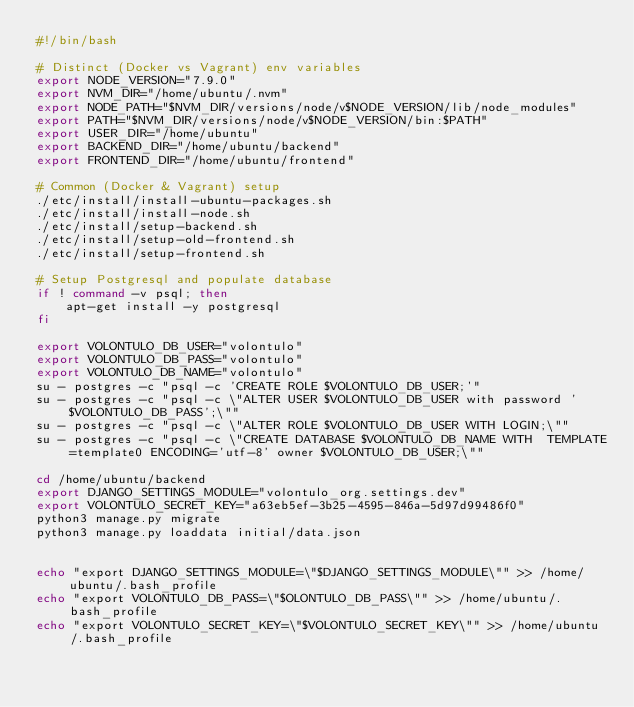<code> <loc_0><loc_0><loc_500><loc_500><_Bash_>#!/bin/bash

# Distinct (Docker vs Vagrant) env variables
export NODE_VERSION="7.9.0"
export NVM_DIR="/home/ubuntu/.nvm"
export NODE_PATH="$NVM_DIR/versions/node/v$NODE_VERSION/lib/node_modules"
export PATH="$NVM_DIR/versions/node/v$NODE_VERSION/bin:$PATH"
export USER_DIR="/home/ubuntu"
export BACKEND_DIR="/home/ubuntu/backend"
export FRONTEND_DIR="/home/ubuntu/frontend"

# Common (Docker & Vagrant) setup
./etc/install/install-ubuntu-packages.sh
./etc/install/install-node.sh
./etc/install/setup-backend.sh
./etc/install/setup-old-frontend.sh
./etc/install/setup-frontend.sh

# Setup Postgresql and populate database
if ! command -v psql; then
    apt-get install -y postgresql
fi

export VOLONTULO_DB_USER="volontulo"
export VOLONTULO_DB_PASS="volontulo"
export VOLONTULO_DB_NAME="volontulo"
su - postgres -c "psql -c 'CREATE ROLE $VOLONTULO_DB_USER;'"
su - postgres -c "psql -c \"ALTER USER $VOLONTULO_DB_USER with password '$VOLONTULO_DB_PASS';\""
su - postgres -c "psql -c \"ALTER ROLE $VOLONTULO_DB_USER WITH LOGIN;\""
su - postgres -c "psql -c \"CREATE DATABASE $VOLONTULO_DB_NAME WITH  TEMPLATE=template0 ENCODING='utf-8' owner $VOLONTULO_DB_USER;\""

cd /home/ubuntu/backend
export DJANGO_SETTINGS_MODULE="volontulo_org.settings.dev"
export VOLONTULO_SECRET_KEY="a63eb5ef-3b25-4595-846a-5d97d99486f0"
python3 manage.py migrate
python3 manage.py loaddata initial/data.json


echo "export DJANGO_SETTINGS_MODULE=\"$DJANGO_SETTINGS_MODULE\"" >> /home/ubuntu/.bash_profile
echo "export VOLONTULO_DB_PASS=\"$OLONTULO_DB_PASS\"" >> /home/ubuntu/.bash_profile
echo "export VOLONTULO_SECRET_KEY=\"$VOLONTULO_SECRET_KEY\"" >> /home/ubuntu/.bash_profile
</code> 